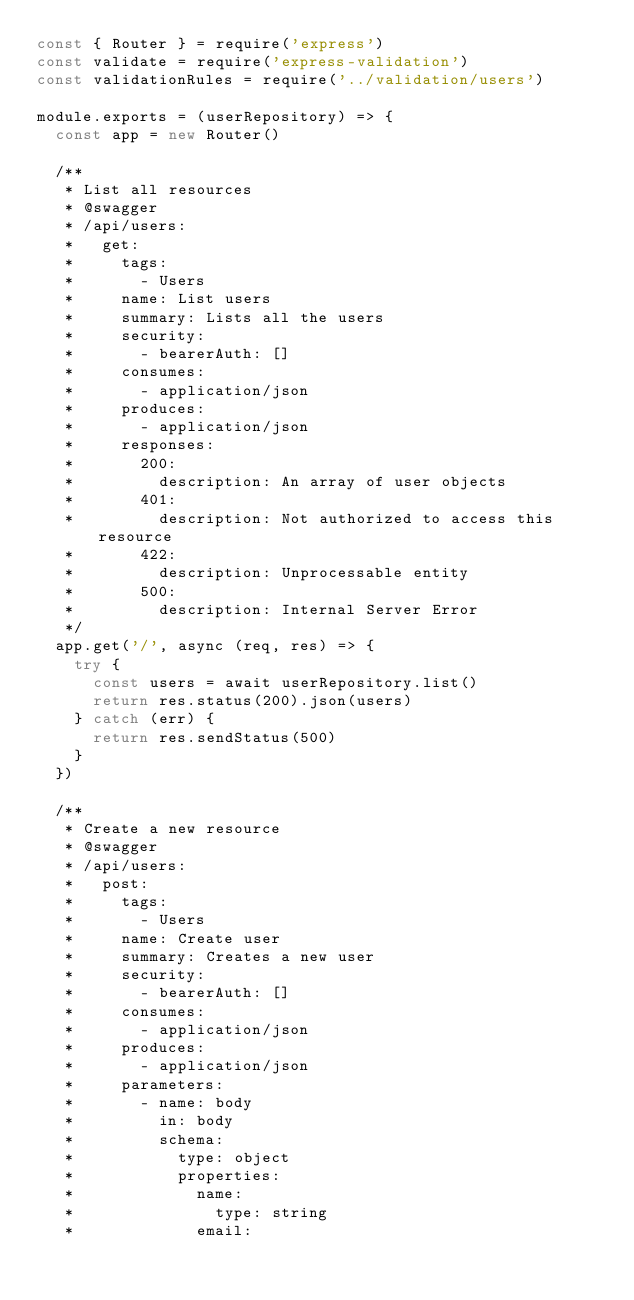<code> <loc_0><loc_0><loc_500><loc_500><_JavaScript_>const { Router } = require('express')
const validate = require('express-validation')
const validationRules = require('../validation/users')

module.exports = (userRepository) => {
  const app = new Router()

  /**
   * List all resources
   * @swagger
   * /api/users:
   *   get:
   *     tags:
   *       - Users
   *     name: List users
   *     summary: Lists all the users
   *     security:
   *       - bearerAuth: []
   *     consumes:
   *       - application/json
   *     produces:
   *       - application/json
   *     responses:
   *       200:
   *         description: An array of user objects
   *       401:
   *         description: Not authorized to access this resource
   *       422:
   *         description: Unprocessable entity
   *       500:
   *         description: Internal Server Error
   */
  app.get('/', async (req, res) => {
    try {
      const users = await userRepository.list()
      return res.status(200).json(users)
    } catch (err) {
      return res.sendStatus(500)
    }
  })

  /**
   * Create a new resource
   * @swagger
   * /api/users:
   *   post:
   *     tags:
   *       - Users
   *     name: Create user
   *     summary: Creates a new user
   *     security:
   *       - bearerAuth: []
   *     consumes:
   *       - application/json
   *     produces:
   *       - application/json
   *     parameters:
   *       - name: body
   *         in: body
   *         schema:
   *           type: object
   *           properties:
   *             name:
   *               type: string
   *             email:</code> 